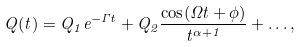<formula> <loc_0><loc_0><loc_500><loc_500>Q ( t ) = Q _ { 1 } e ^ { - \Gamma t } + Q _ { 2 } \frac { \cos ( \Omega t + \phi ) } { t ^ { \alpha + 1 } } + \dots ,</formula> 